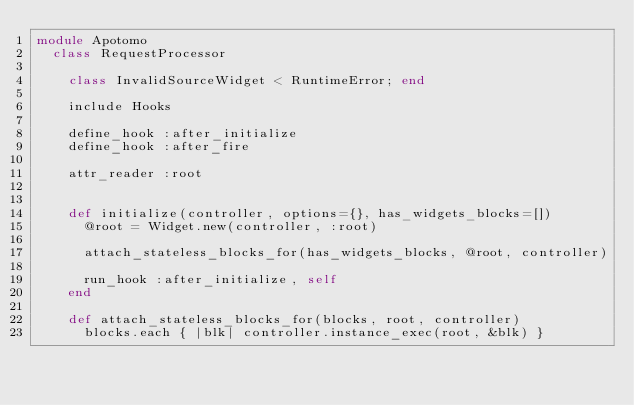Convert code to text. <code><loc_0><loc_0><loc_500><loc_500><_Ruby_>module Apotomo
  class RequestProcessor

    class InvalidSourceWidget < RuntimeError; end

    include Hooks
    
    define_hook :after_initialize
    define_hook :after_fire
    
    attr_reader :root
    
    
    def initialize(controller, options={}, has_widgets_blocks=[])
      @root = Widget.new(controller, :root)
      
      attach_stateless_blocks_for(has_widgets_blocks, @root, controller)
      
      run_hook :after_initialize, self
    end
    
    def attach_stateless_blocks_for(blocks, root, controller)
      blocks.each { |blk| controller.instance_exec(root, &blk) }</code> 